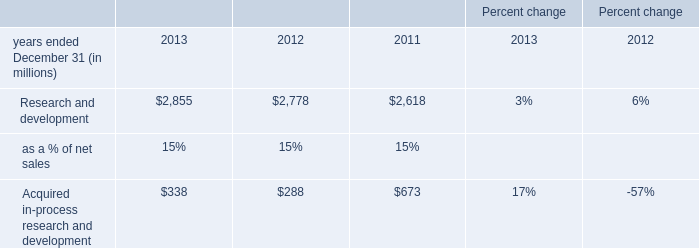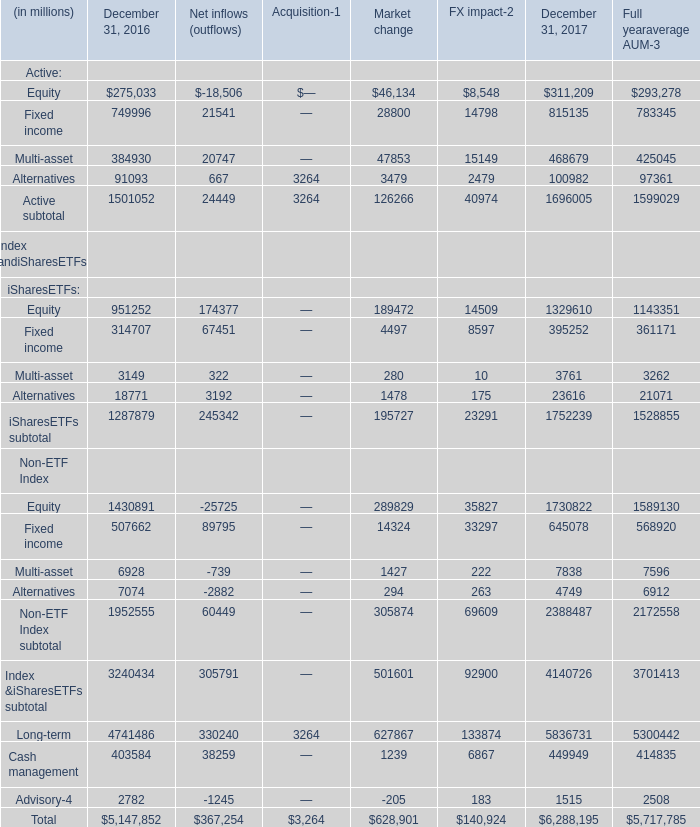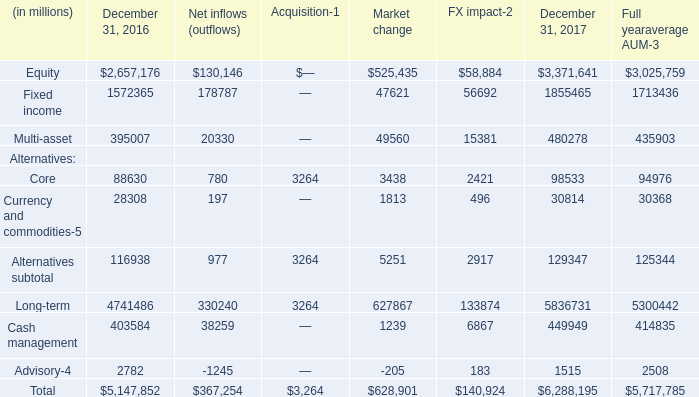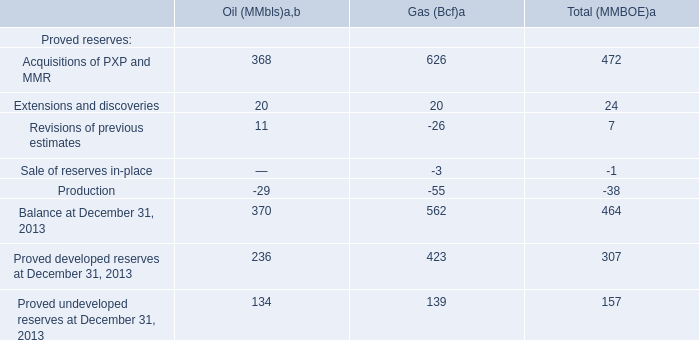What's the average of Cash management and Advisory in 2016? (in million) 
Computations: ((403584 + 2782) / 2)
Answer: 203183.0. 